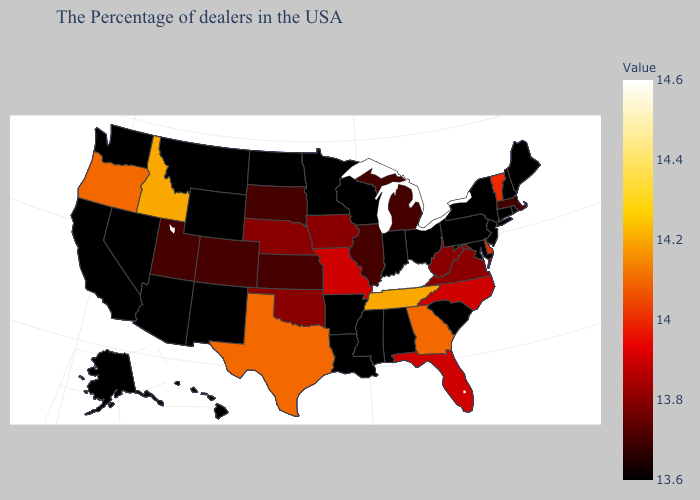Which states have the highest value in the USA?
Quick response, please. Kentucky. Among the states that border Washington , which have the highest value?
Answer briefly. Idaho. Among the states that border New York , does Vermont have the lowest value?
Be succinct. No. Which states have the lowest value in the West?
Keep it brief. Wyoming, New Mexico, Montana, Arizona, Nevada, California, Washington, Alaska, Hawaii. 